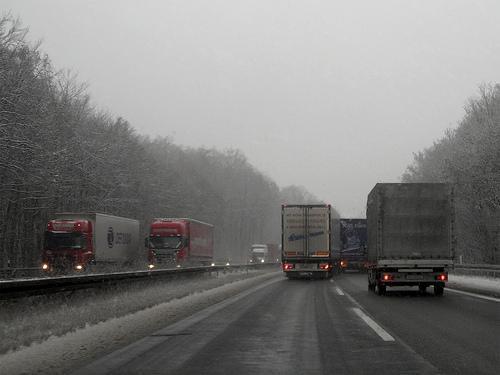How many red trucks are in the picture?
Give a very brief answer. 2. 